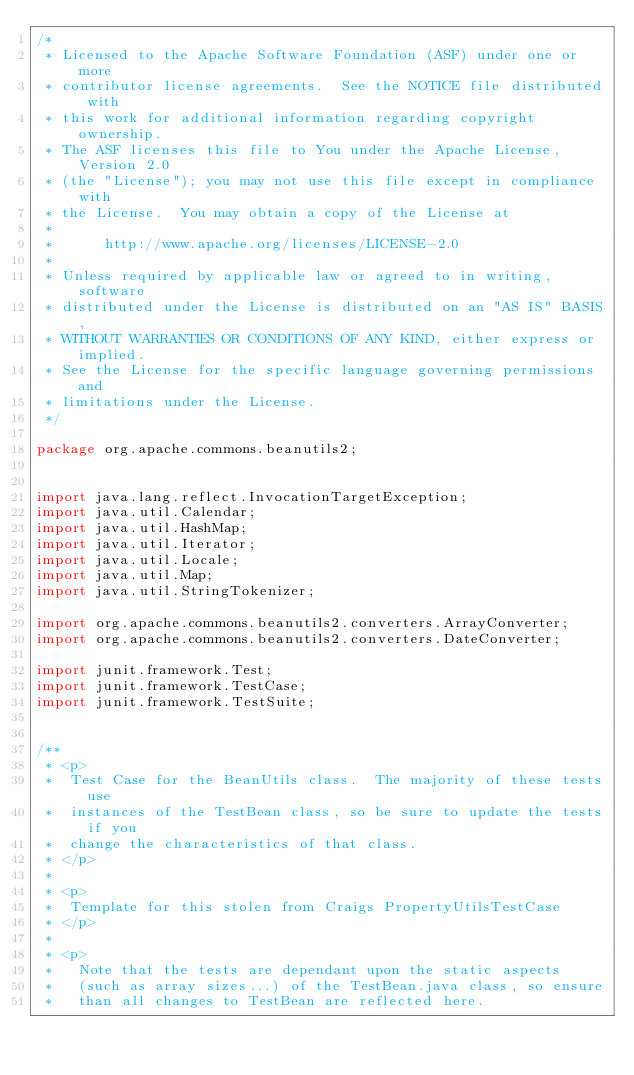Convert code to text. <code><loc_0><loc_0><loc_500><loc_500><_Java_>/*
 * Licensed to the Apache Software Foundation (ASF) under one or more
 * contributor license agreements.  See the NOTICE file distributed with
 * this work for additional information regarding copyright ownership.
 * The ASF licenses this file to You under the Apache License, Version 2.0
 * (the "License"); you may not use this file except in compliance with
 * the License.  You may obtain a copy of the License at
 *
 *      http://www.apache.org/licenses/LICENSE-2.0
 *
 * Unless required by applicable law or agreed to in writing, software
 * distributed under the License is distributed on an "AS IS" BASIS,
 * WITHOUT WARRANTIES OR CONDITIONS OF ANY KIND, either express or implied.
 * See the License for the specific language governing permissions and
 * limitations under the License.
 */

package org.apache.commons.beanutils2;


import java.lang.reflect.InvocationTargetException;
import java.util.Calendar;
import java.util.HashMap;
import java.util.Iterator;
import java.util.Locale;
import java.util.Map;
import java.util.StringTokenizer;

import org.apache.commons.beanutils2.converters.ArrayConverter;
import org.apache.commons.beanutils2.converters.DateConverter;

import junit.framework.Test;
import junit.framework.TestCase;
import junit.framework.TestSuite;


/**
 * <p>
 *  Test Case for the BeanUtils class.  The majority of these tests use
 *  instances of the TestBean class, so be sure to update the tests if you
 *  change the characteristics of that class.
 * </p>
 *
 * <p>
 *  Template for this stolen from Craigs PropertyUtilsTestCase
 * </p>
 *
 * <p>
 *   Note that the tests are dependant upon the static aspects
 *   (such as array sizes...) of the TestBean.java class, so ensure
 *   than all changes to TestBean are reflected here.</code> 